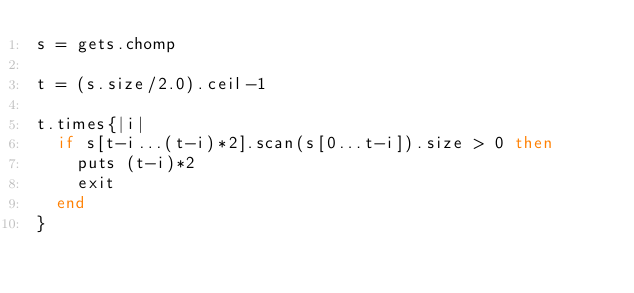<code> <loc_0><loc_0><loc_500><loc_500><_Ruby_>s = gets.chomp

t = (s.size/2.0).ceil-1

t.times{|i|
  if s[t-i...(t-i)*2].scan(s[0...t-i]).size > 0 then
    puts (t-i)*2
    exit
  end
}</code> 